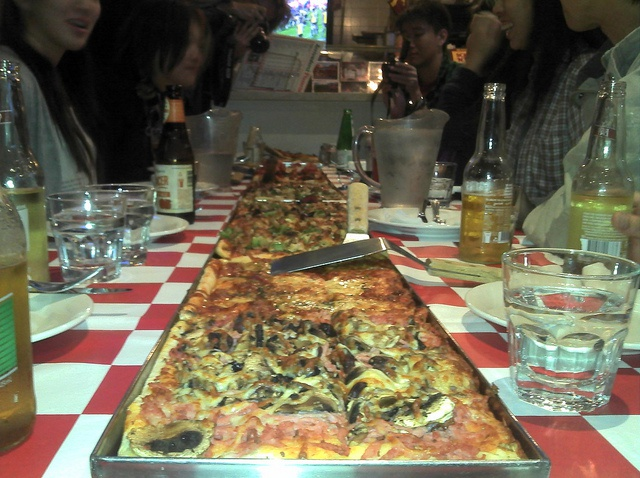Describe the objects in this image and their specific colors. I can see dining table in black, gray, olive, brown, and tan tones, pizza in black, tan, and gray tones, cup in black, darkgray, lightgreen, and gray tones, people in black and darkgreen tones, and people in black and gray tones in this image. 